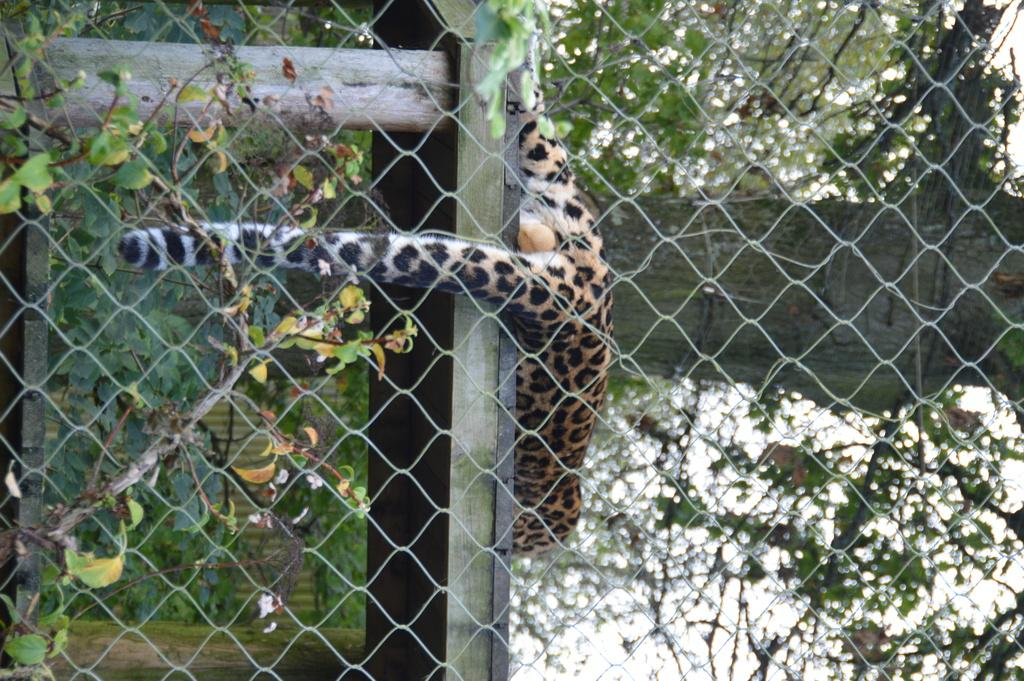What type of animal can be seen in the image? There is an animal in the image, but its specific type cannot be determined from the provided facts. What is the mesh used for in the image? The mesh is present in the image, but its purpose or function cannot be determined from the provided facts. What is the pole used for in the image? The pole is present in the image, but its purpose or function cannot be determined from the provided facts. What type of vegetation is present in the image? Leaves are present in the image, but their specific type or context cannot be determined from the provided facts. How would you describe the image's quality on the right side? The right side of the image is slightly blurred. What type of nut is being cracked by the animal in the image? There is no nut present in the image, and the specific type of animal cannot be determined from the provided facts. 